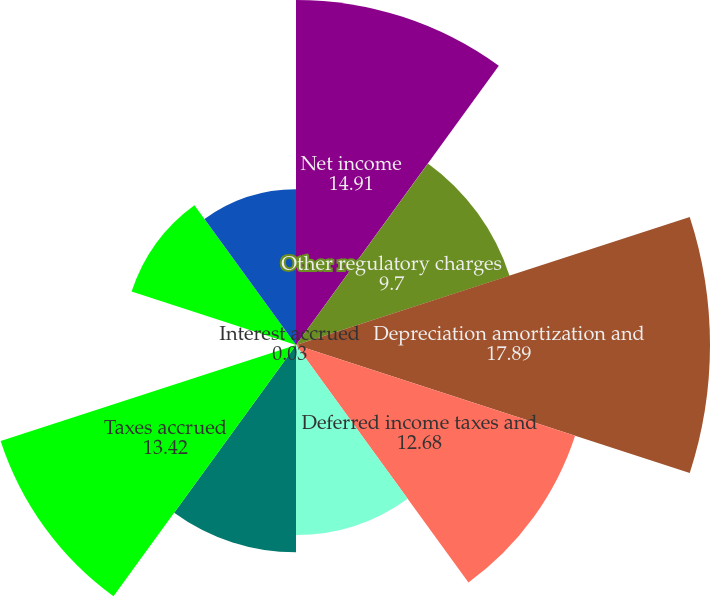Convert chart to OTSL. <chart><loc_0><loc_0><loc_500><loc_500><pie_chart><fcel>Net income<fcel>Other regulatory charges<fcel>Depreciation amortization and<fcel>Deferred income taxes and<fcel>Receivables<fcel>Accounts payable<fcel>Taxes accrued<fcel>Interest accrued<fcel>Deferred fuel costs<fcel>Other working capital accounts<nl><fcel>14.91%<fcel>9.7%<fcel>17.89%<fcel>12.68%<fcel>8.21%<fcel>8.96%<fcel>13.42%<fcel>0.03%<fcel>7.47%<fcel>6.73%<nl></chart> 